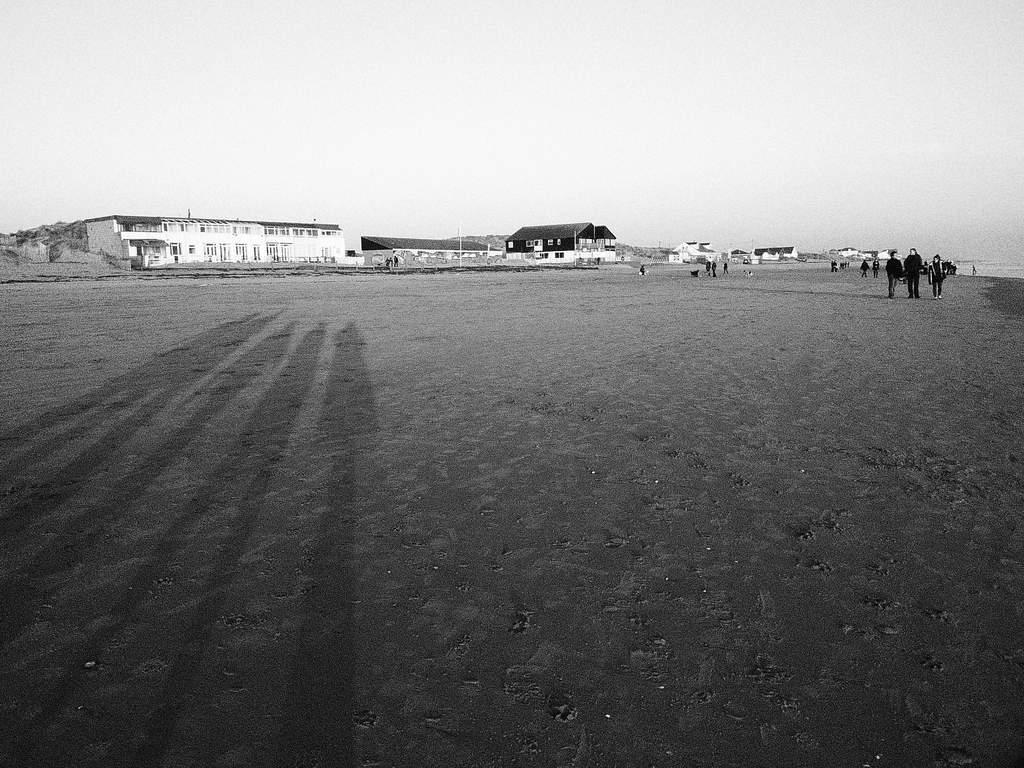What is the main feature of the image? There is a big ground in the image. What are the people in the image doing? There are people walking on the ground. What can be seen in the background of the image? There is a wooden shade house and a white house with many windows in the background. What type of notebook is being used by the people walking on the ground? There is no notebook present in the image; the people are simply walking on the ground. How many oranges are hanging from the wooden shade house in the background? There are no oranges visible in the image; the wooden shade house is the only structure mentioned in the background. 